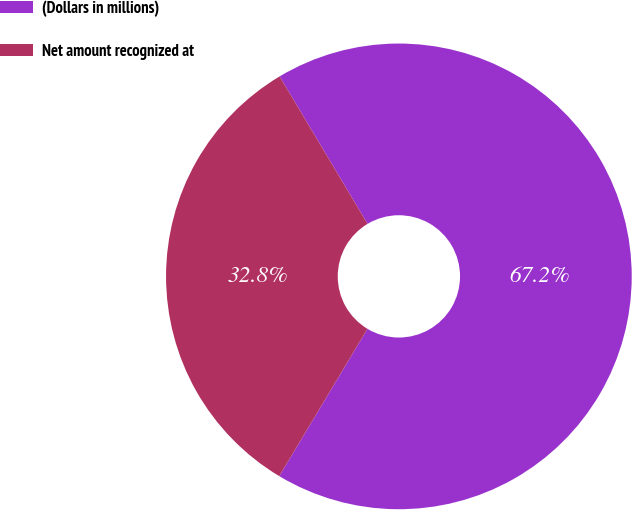Convert chart to OTSL. <chart><loc_0><loc_0><loc_500><loc_500><pie_chart><fcel>(Dollars in millions)<fcel>Net amount recognized at<nl><fcel>67.15%<fcel>32.85%<nl></chart> 